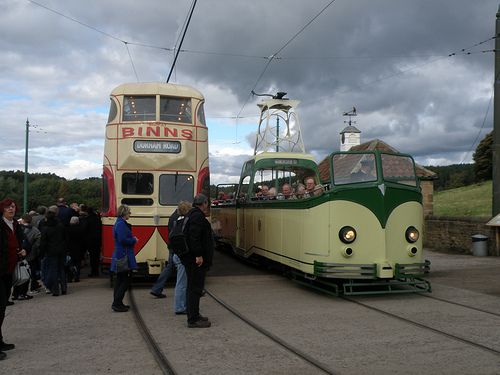<image>
Is the man under the train? No. The man is not positioned under the train. The vertical relationship between these objects is different. 